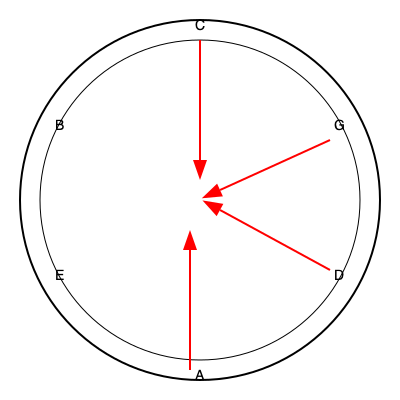Analyze the harmonic structure of the chord progression C - G - D - A - E shown in the circle of fifths diagram. What is the overall tonal movement, and how does this progression relate to the concept of modulation? Provide your analysis in terms of the number of perfect fifth movements and its implications for the tonal center. To analyze this chord progression using the circle of fifths diagram, let's follow these steps:

1. Identify the movement:
   The progression moves clockwise around the circle of fifths: C → G → D → A → E

2. Count the number of perfect fifth movements:
   C to G: 1 fifth
   G to D: 1 fifth
   D to A: 1 fifth
   A to E: 1 fifth
   Total: 4 perfect fifth movements

3. Analyze the tonal implications:
   a) Each movement of a perfect fifth represents a significant shift in the tonal center.
   b) Moving clockwise on the circle of fifths creates a sense of brightening or increasing tension.

4. Consider modulation:
   a) This progression doesn't firmly establish a new key, but it continuously shifts the tonal center.
   b) It can be seen as a series of temporary tonicizations, each chord briefly serving as a temporary tonic.

5. Evaluate the overall tonal movement:
   a) The progression spans 4 perfect fifths, which is equivalent to a major third (C to E).
   b) This creates a significant departure from the original tonal center of C.

6. Implications for composition and performance:
   a) This progression creates a sense of constant forward motion and increasing brightness.
   b) It can be used to build tension or to transition between distantly related keys.
   c) For a pianist, this progression requires attention to voice leading and may involve challenging key changes.
Answer: 4 perfect fifth movements clockwise; continuous shift of tonal center without firm modulation; overall brightening effect spanning a major third (C to E). 